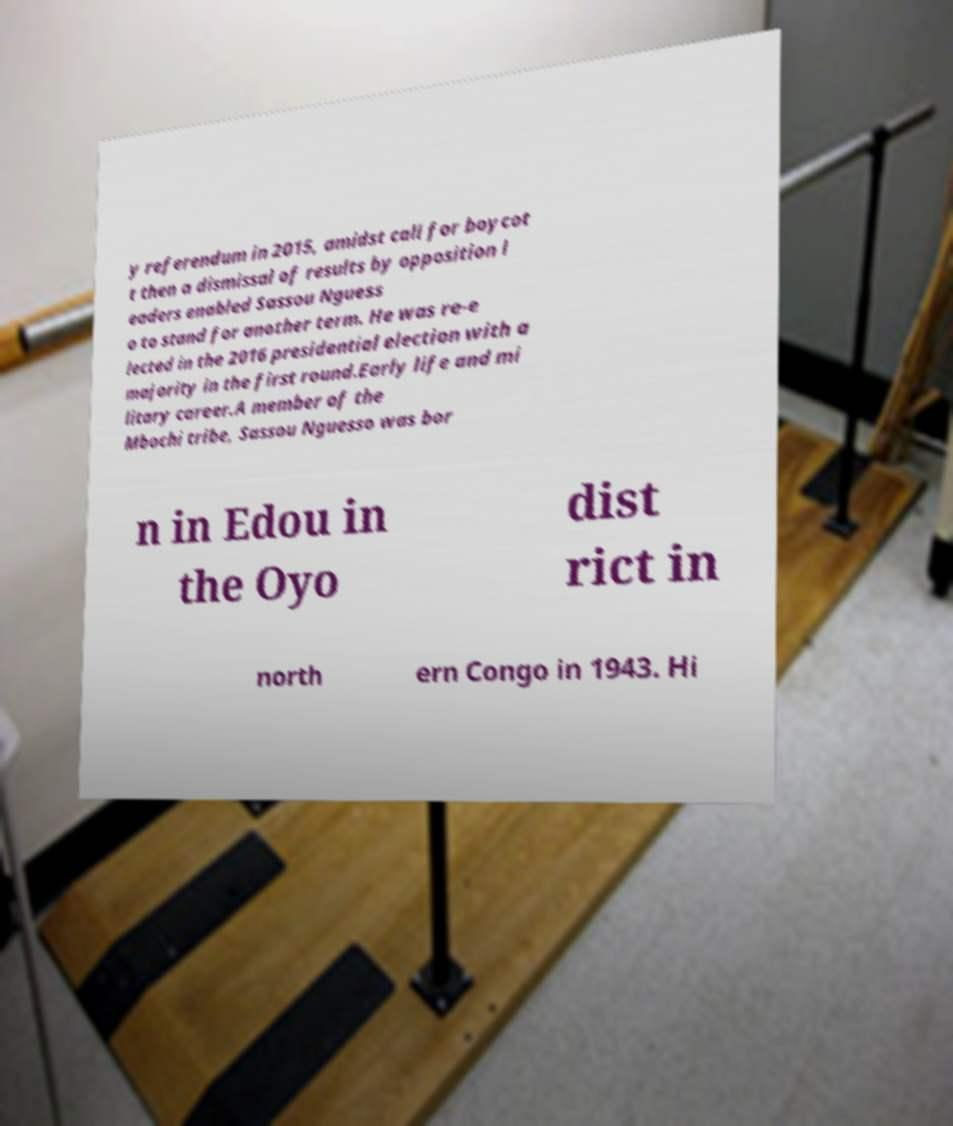Could you extract and type out the text from this image? y referendum in 2015, amidst call for boycot t then a dismissal of results by opposition l eaders enabled Sassou Nguess o to stand for another term. He was re-e lected in the 2016 presidential election with a majority in the first round.Early life and mi litary career.A member of the Mbochi tribe, Sassou Nguesso was bor n in Edou in the Oyo dist rict in north ern Congo in 1943. Hi 